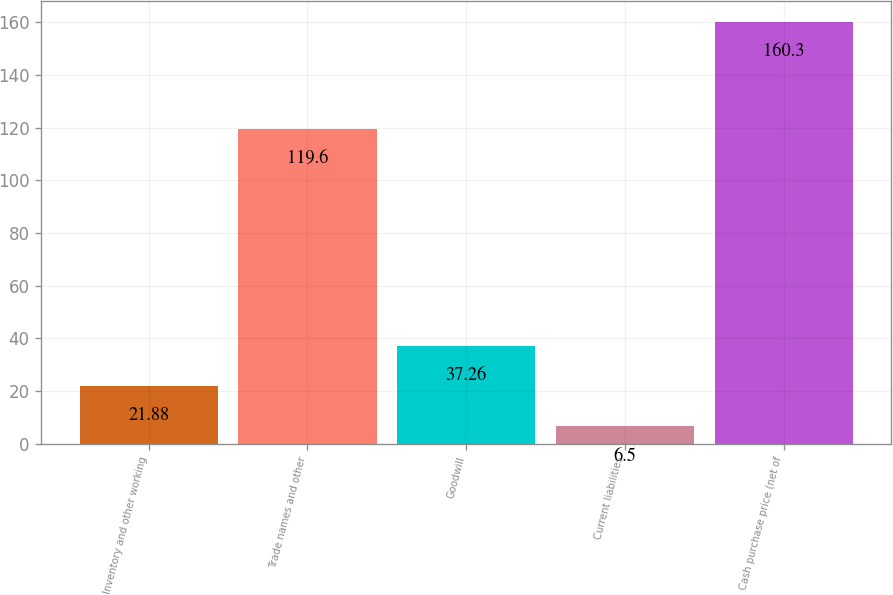Convert chart. <chart><loc_0><loc_0><loc_500><loc_500><bar_chart><fcel>Inventory and other working<fcel>Trade names and other<fcel>Goodwill<fcel>Current liabilities<fcel>Cash purchase price (net of<nl><fcel>21.88<fcel>119.6<fcel>37.26<fcel>6.5<fcel>160.3<nl></chart> 